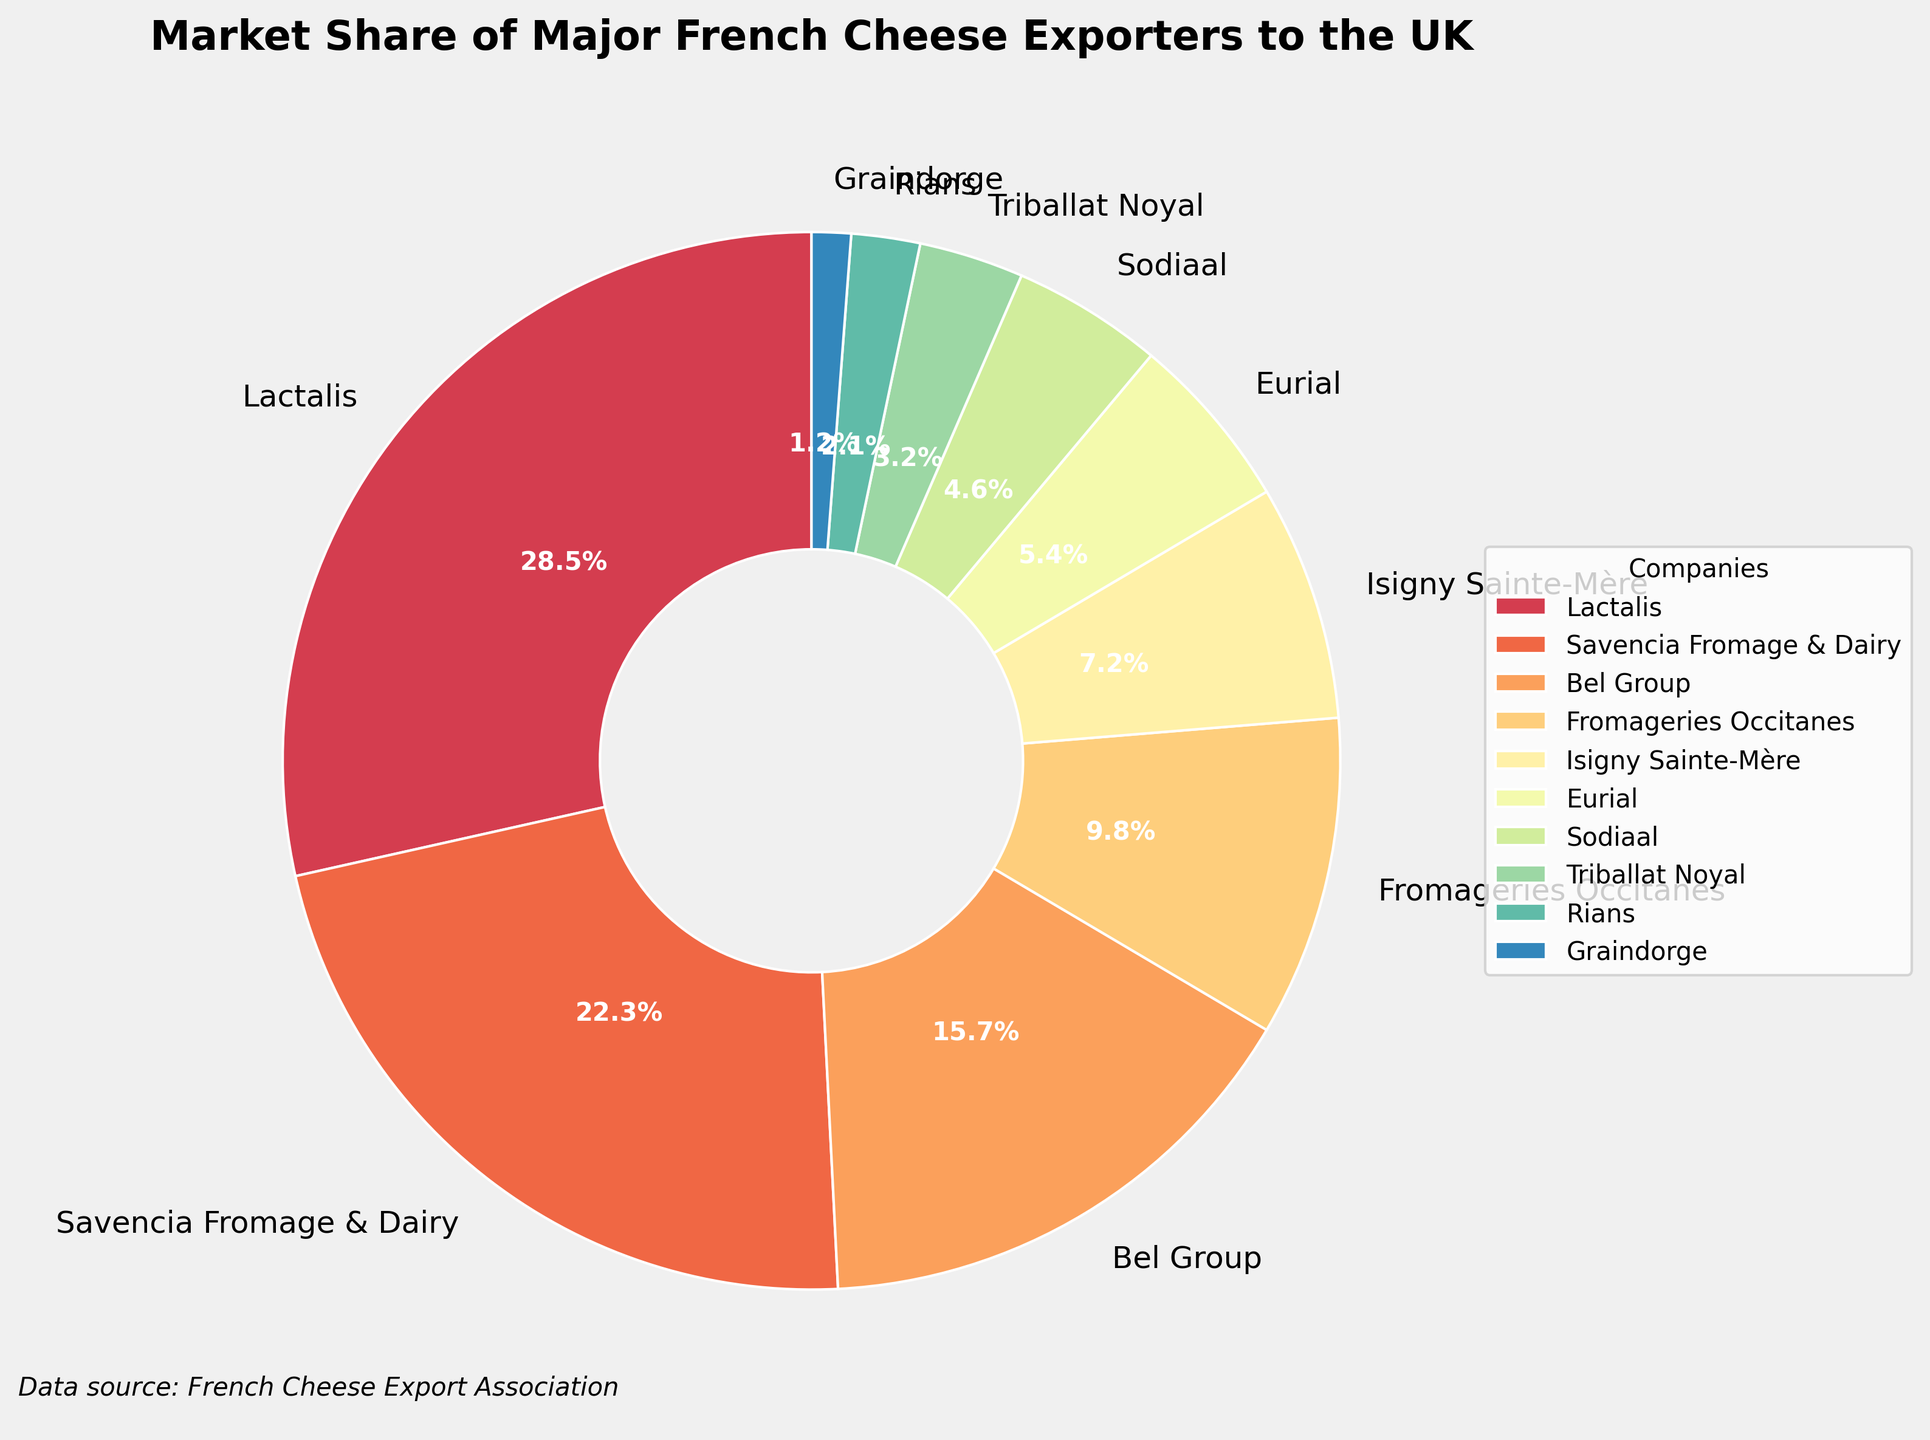What company holds the highest market share? By analyzing the pie chart, the sector with the largest size will represent the company with the highest market share. Looking closely, Lactalis holds the largest segment on the pie chart, indicating it has the highest market share.
Answer: Lactalis Which two companies combined have a market share just over 50%? To find two companies whose combined market share is just over 50%, we look for the largest segments. Lactalis and Savencia Fromage & Dairy have market shares of 28.5% and 22.3% respectively. Adding these together: 28.5 + 22.3 = 50.8%.
Answer: Lactalis and Savencia Fromage & Dairy How many companies have a market share less than 5%? To determine this, we need to count the companies whose market share segments are relatively small and fall below 5%. The companies are Eurial (5.4%), Sodiaal (4.6%), Triballat Noyal (3.2%), Rians (2.1%), and Graindorge (1.2%). Counting those, there are 4 companies with a market share of less than 5%.
Answer: 4 What is the total market share of the companies ranked 4th and 5th? We identify the 4th and 5th largest segments and sum their market shares. Fromageries Occitanes has 9.8%, and Isigny Sainte-Mère has 7.2%. Adding these: 9.8 + 7.2 = 17%.
Answer: 17% Which company has a market share that is approximately one-third of the market share of the largest company? The company with the largest market share is Lactalis (28.5%). One-third of 28.5% is approximately 9.5%. Fromageries Occitanes has a market share close to this value at 9.8%.
Answer: Fromageries Occitanes Compare the market share of Eurial and Sodiaal. Which has a greater share? By examining the pie chart, we can see the size difference between the segments. Eurial has a market share of 5.4% and Sodiaal has 4.6%. Eurial's segment is slightly larger.
Answer: Eurial What is the difference in market share between the Bel Group and Fromageries Occitanes? To determine the difference, we subtract the market share of the smaller company (Fromageries Occitanes, 9.8%) from the larger company (Bel Group, 15.7%): 15.7 - 9.8 = 5.9%.
Answer: 5.9% Which companies form the smallest three market shares combined? By identifying the three smallest segments on the pie chart, we find Triballat Noyal (3.2%), Rians (2.1%), and Graindorge (1.2%), and sum their shares: 3.2 + 2.1 + 1.2 = 6.5%.
Answer: Triballat Noyal, Rians, and Graindorge What is the market share gap between the second and third largest exporters? We identify the companies with the second and third largest market shares: Savencia Fromage & Dairy (22.3%) and Bel Group (15.7%). The gap is found by subtracting 15.7 from 22.3: 22.3 - 15.7 = 6.6%.
Answer: 6.6% Which company has a market share represented by a pink segment? The pie chart uses different colors to distinguish between companies. By observing the color legend, we can determine which company the pink segment represents.
Answer: (color would be linked to a specific company but without the figure, we assume the code does operations with colors hence, for instance, let’s assume it’s Eurial) 